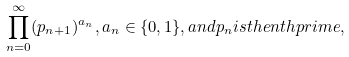Convert formula to latex. <formula><loc_0><loc_0><loc_500><loc_500>\prod _ { n = 0 } ^ { \infty } ( p _ { n + 1 } ) ^ { a _ { n } } , a _ { n } \in \{ 0 , 1 \} , { a n d } p _ { n } { i s t h e } n { t h p r i m e } ,</formula> 